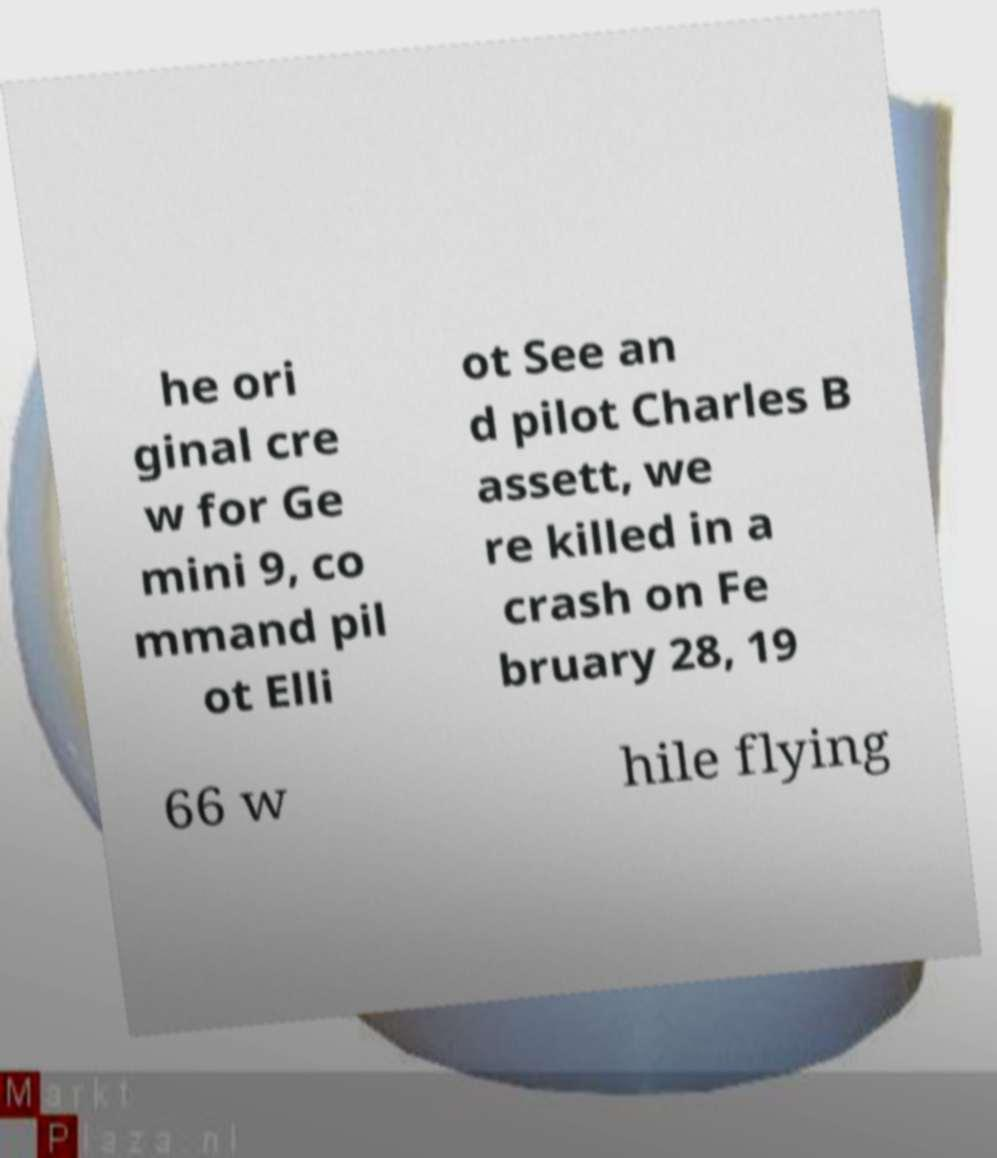Please identify and transcribe the text found in this image. he ori ginal cre w for Ge mini 9, co mmand pil ot Elli ot See an d pilot Charles B assett, we re killed in a crash on Fe bruary 28, 19 66 w hile flying 